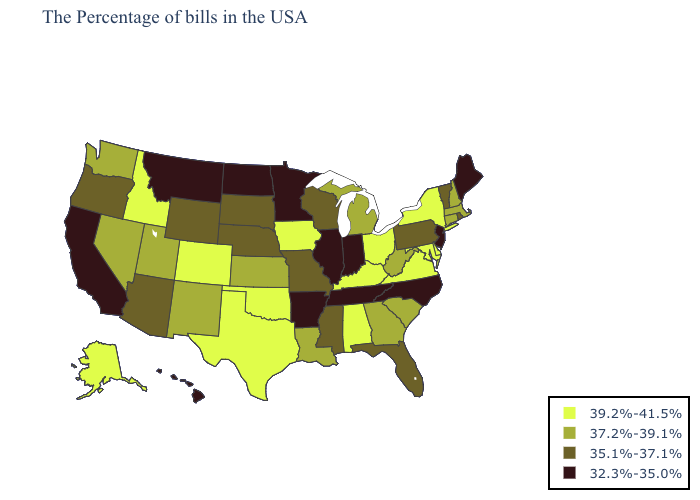What is the value of Louisiana?
Write a very short answer. 37.2%-39.1%. What is the lowest value in the USA?
Answer briefly. 32.3%-35.0%. Name the states that have a value in the range 37.2%-39.1%?
Keep it brief. Massachusetts, New Hampshire, Connecticut, South Carolina, West Virginia, Georgia, Michigan, Louisiana, Kansas, New Mexico, Utah, Nevada, Washington. Does the map have missing data?
Short answer required. No. What is the lowest value in states that border Mississippi?
Answer briefly. 32.3%-35.0%. Does Indiana have the highest value in the MidWest?
Short answer required. No. What is the lowest value in states that border Maine?
Give a very brief answer. 37.2%-39.1%. Which states have the lowest value in the USA?
Be succinct. Maine, New Jersey, North Carolina, Indiana, Tennessee, Illinois, Arkansas, Minnesota, North Dakota, Montana, California, Hawaii. Name the states that have a value in the range 37.2%-39.1%?
Keep it brief. Massachusetts, New Hampshire, Connecticut, South Carolina, West Virginia, Georgia, Michigan, Louisiana, Kansas, New Mexico, Utah, Nevada, Washington. Name the states that have a value in the range 35.1%-37.1%?
Give a very brief answer. Rhode Island, Vermont, Pennsylvania, Florida, Wisconsin, Mississippi, Missouri, Nebraska, South Dakota, Wyoming, Arizona, Oregon. Does Iowa have the lowest value in the USA?
Answer briefly. No. Does the map have missing data?
Quick response, please. No. Which states have the lowest value in the South?
Short answer required. North Carolina, Tennessee, Arkansas. Which states hav the highest value in the MidWest?
Give a very brief answer. Ohio, Iowa. Does the first symbol in the legend represent the smallest category?
Give a very brief answer. No. 